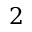Convert formula to latex. <formula><loc_0><loc_0><loc_500><loc_500>2</formula> 